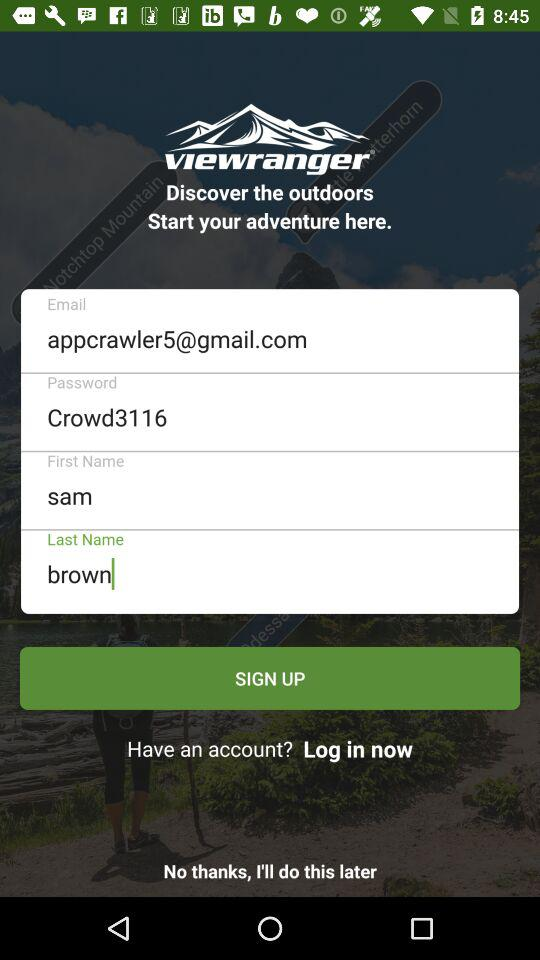What is the name of the application? The name of the application is "viewranger". 